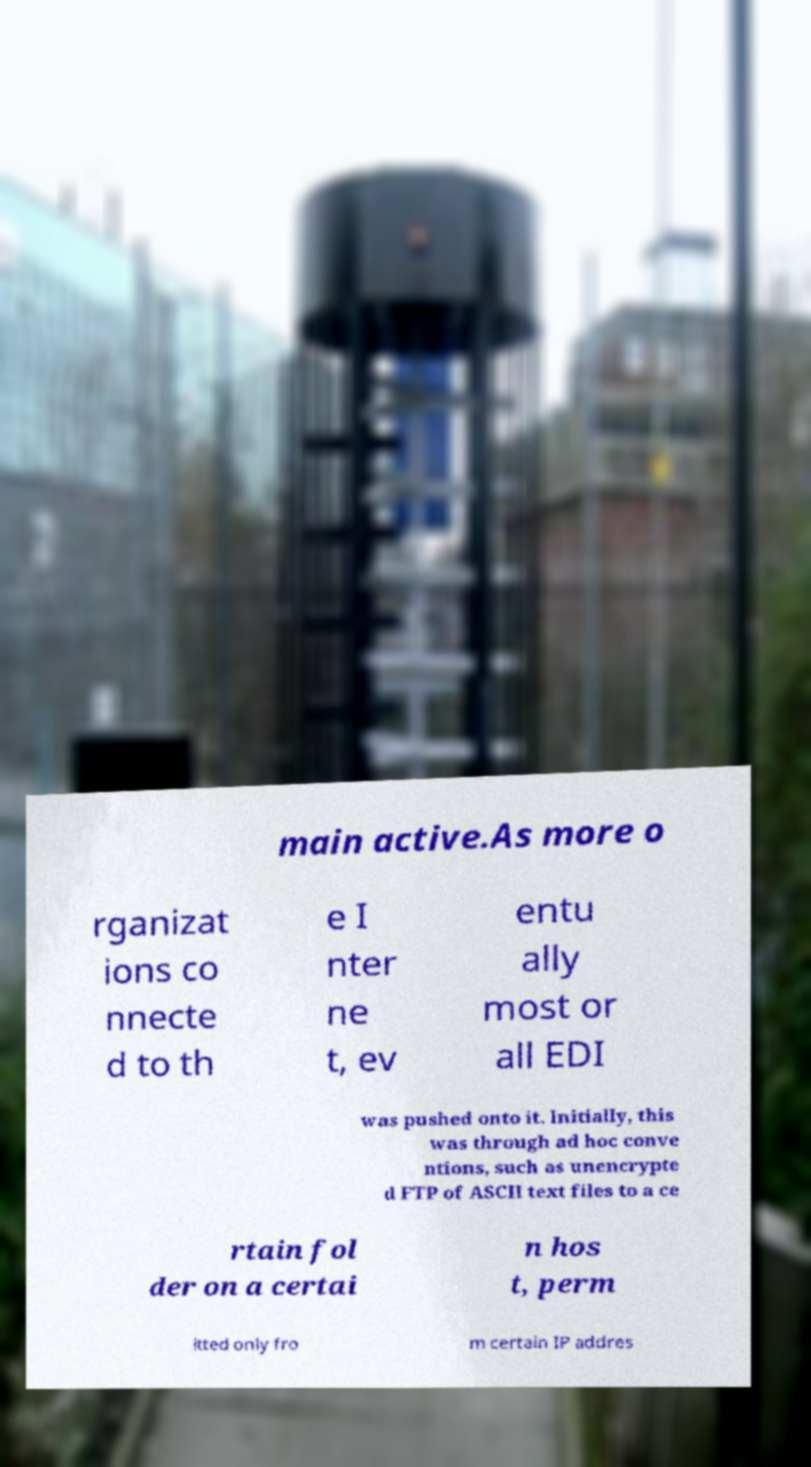Could you assist in decoding the text presented in this image and type it out clearly? main active.As more o rganizat ions co nnecte d to th e I nter ne t, ev entu ally most or all EDI was pushed onto it. Initially, this was through ad hoc conve ntions, such as unencrypte d FTP of ASCII text files to a ce rtain fol der on a certai n hos t, perm itted only fro m certain IP addres 